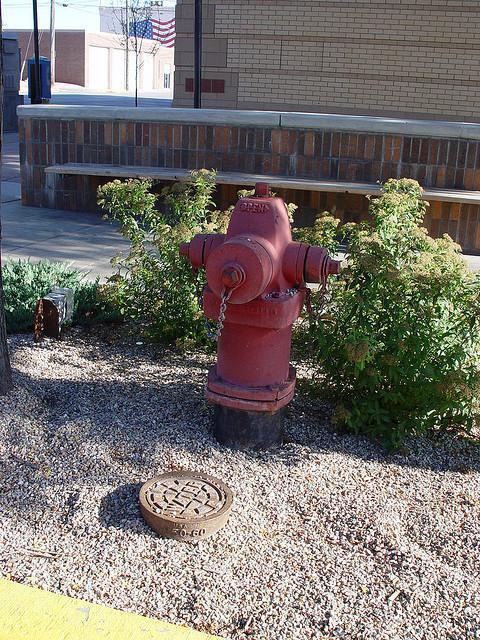How many dogs are on the bed?
Give a very brief answer. 0. 